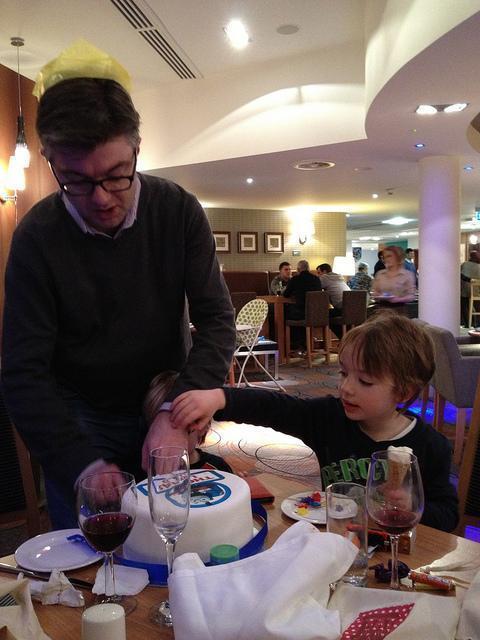Which person is likely celebrating a birthday?
Choose the right answer from the provided options to respond to the question.
Options: Unknown, boy, man, woman. Boy. 